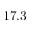<formula> <loc_0><loc_0><loc_500><loc_500>1 7 . 3</formula> 